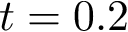Convert formula to latex. <formula><loc_0><loc_0><loc_500><loc_500>t = 0 . 2</formula> 